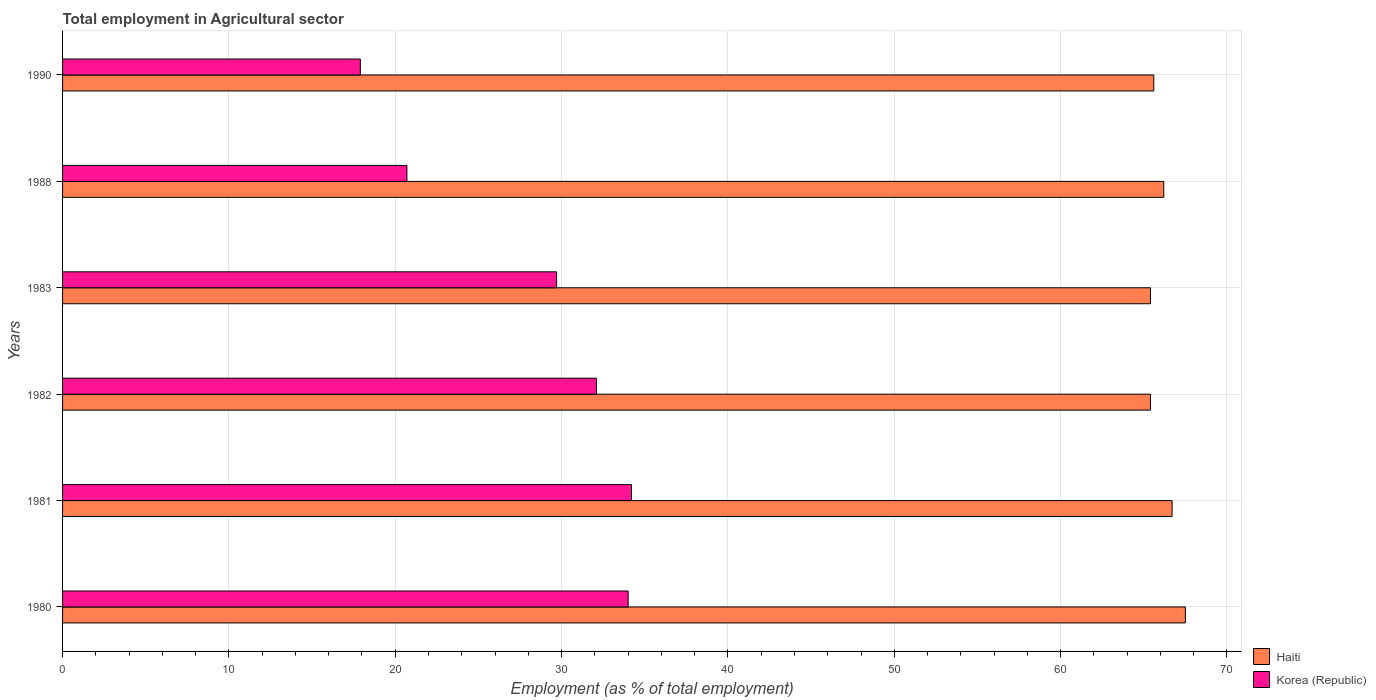Are the number of bars on each tick of the Y-axis equal?
Keep it short and to the point. Yes. How many bars are there on the 3rd tick from the bottom?
Ensure brevity in your answer.  2. What is the label of the 1st group of bars from the top?
Your answer should be very brief. 1990. What is the employment in agricultural sector in Haiti in 1980?
Your response must be concise. 67.5. Across all years, what is the maximum employment in agricultural sector in Haiti?
Give a very brief answer. 67.5. Across all years, what is the minimum employment in agricultural sector in Haiti?
Your answer should be very brief. 65.4. In which year was the employment in agricultural sector in Korea (Republic) maximum?
Ensure brevity in your answer.  1981. In which year was the employment in agricultural sector in Korea (Republic) minimum?
Keep it short and to the point. 1990. What is the total employment in agricultural sector in Korea (Republic) in the graph?
Your response must be concise. 168.6. What is the difference between the employment in agricultural sector in Haiti in 1983 and that in 1988?
Keep it short and to the point. -0.8. What is the difference between the employment in agricultural sector in Korea (Republic) in 1981 and the employment in agricultural sector in Haiti in 1980?
Your answer should be compact. -33.3. What is the average employment in agricultural sector in Korea (Republic) per year?
Offer a terse response. 28.1. In the year 1988, what is the difference between the employment in agricultural sector in Korea (Republic) and employment in agricultural sector in Haiti?
Provide a succinct answer. -45.5. In how many years, is the employment in agricultural sector in Korea (Republic) greater than 44 %?
Your answer should be compact. 0. What is the ratio of the employment in agricultural sector in Korea (Republic) in 1980 to that in 1982?
Offer a very short reply. 1.06. What is the difference between the highest and the second highest employment in agricultural sector in Korea (Republic)?
Your response must be concise. 0.2. What is the difference between the highest and the lowest employment in agricultural sector in Haiti?
Provide a short and direct response. 2.1. In how many years, is the employment in agricultural sector in Korea (Republic) greater than the average employment in agricultural sector in Korea (Republic) taken over all years?
Offer a terse response. 4. What does the 2nd bar from the top in 1990 represents?
Ensure brevity in your answer.  Haiti. Are all the bars in the graph horizontal?
Your answer should be compact. Yes. Are the values on the major ticks of X-axis written in scientific E-notation?
Your response must be concise. No. Does the graph contain grids?
Offer a very short reply. Yes. How are the legend labels stacked?
Your answer should be compact. Vertical. What is the title of the graph?
Provide a short and direct response. Total employment in Agricultural sector. What is the label or title of the X-axis?
Make the answer very short. Employment (as % of total employment). What is the label or title of the Y-axis?
Give a very brief answer. Years. What is the Employment (as % of total employment) of Haiti in 1980?
Give a very brief answer. 67.5. What is the Employment (as % of total employment) in Korea (Republic) in 1980?
Ensure brevity in your answer.  34. What is the Employment (as % of total employment) of Haiti in 1981?
Ensure brevity in your answer.  66.7. What is the Employment (as % of total employment) of Korea (Republic) in 1981?
Give a very brief answer. 34.2. What is the Employment (as % of total employment) of Haiti in 1982?
Offer a very short reply. 65.4. What is the Employment (as % of total employment) of Korea (Republic) in 1982?
Provide a short and direct response. 32.1. What is the Employment (as % of total employment) in Haiti in 1983?
Give a very brief answer. 65.4. What is the Employment (as % of total employment) of Korea (Republic) in 1983?
Provide a short and direct response. 29.7. What is the Employment (as % of total employment) of Haiti in 1988?
Offer a very short reply. 66.2. What is the Employment (as % of total employment) in Korea (Republic) in 1988?
Your response must be concise. 20.7. What is the Employment (as % of total employment) in Haiti in 1990?
Your response must be concise. 65.6. What is the Employment (as % of total employment) in Korea (Republic) in 1990?
Provide a short and direct response. 17.9. Across all years, what is the maximum Employment (as % of total employment) in Haiti?
Offer a terse response. 67.5. Across all years, what is the maximum Employment (as % of total employment) in Korea (Republic)?
Give a very brief answer. 34.2. Across all years, what is the minimum Employment (as % of total employment) in Haiti?
Offer a very short reply. 65.4. Across all years, what is the minimum Employment (as % of total employment) of Korea (Republic)?
Provide a succinct answer. 17.9. What is the total Employment (as % of total employment) in Haiti in the graph?
Give a very brief answer. 396.8. What is the total Employment (as % of total employment) in Korea (Republic) in the graph?
Give a very brief answer. 168.6. What is the difference between the Employment (as % of total employment) of Haiti in 1980 and that in 1981?
Provide a succinct answer. 0.8. What is the difference between the Employment (as % of total employment) of Korea (Republic) in 1980 and that in 1981?
Your response must be concise. -0.2. What is the difference between the Employment (as % of total employment) of Haiti in 1980 and that in 1982?
Make the answer very short. 2.1. What is the difference between the Employment (as % of total employment) in Korea (Republic) in 1980 and that in 1982?
Your answer should be compact. 1.9. What is the difference between the Employment (as % of total employment) of Haiti in 1980 and that in 1988?
Ensure brevity in your answer.  1.3. What is the difference between the Employment (as % of total employment) of Haiti in 1980 and that in 1990?
Ensure brevity in your answer.  1.9. What is the difference between the Employment (as % of total employment) of Korea (Republic) in 1980 and that in 1990?
Provide a short and direct response. 16.1. What is the difference between the Employment (as % of total employment) in Korea (Republic) in 1981 and that in 1982?
Offer a terse response. 2.1. What is the difference between the Employment (as % of total employment) of Korea (Republic) in 1981 and that in 1983?
Provide a short and direct response. 4.5. What is the difference between the Employment (as % of total employment) in Haiti in 1981 and that in 1988?
Provide a succinct answer. 0.5. What is the difference between the Employment (as % of total employment) of Korea (Republic) in 1981 and that in 1988?
Offer a very short reply. 13.5. What is the difference between the Employment (as % of total employment) of Korea (Republic) in 1981 and that in 1990?
Provide a succinct answer. 16.3. What is the difference between the Employment (as % of total employment) of Korea (Republic) in 1982 and that in 1983?
Make the answer very short. 2.4. What is the difference between the Employment (as % of total employment) in Haiti in 1982 and that in 1990?
Offer a terse response. -0.2. What is the difference between the Employment (as % of total employment) of Korea (Republic) in 1983 and that in 1988?
Keep it short and to the point. 9. What is the difference between the Employment (as % of total employment) of Haiti in 1983 and that in 1990?
Offer a very short reply. -0.2. What is the difference between the Employment (as % of total employment) of Korea (Republic) in 1988 and that in 1990?
Make the answer very short. 2.8. What is the difference between the Employment (as % of total employment) of Haiti in 1980 and the Employment (as % of total employment) of Korea (Republic) in 1981?
Give a very brief answer. 33.3. What is the difference between the Employment (as % of total employment) in Haiti in 1980 and the Employment (as % of total employment) in Korea (Republic) in 1982?
Provide a succinct answer. 35.4. What is the difference between the Employment (as % of total employment) of Haiti in 1980 and the Employment (as % of total employment) of Korea (Republic) in 1983?
Offer a terse response. 37.8. What is the difference between the Employment (as % of total employment) of Haiti in 1980 and the Employment (as % of total employment) of Korea (Republic) in 1988?
Your answer should be very brief. 46.8. What is the difference between the Employment (as % of total employment) in Haiti in 1980 and the Employment (as % of total employment) in Korea (Republic) in 1990?
Your answer should be very brief. 49.6. What is the difference between the Employment (as % of total employment) in Haiti in 1981 and the Employment (as % of total employment) in Korea (Republic) in 1982?
Make the answer very short. 34.6. What is the difference between the Employment (as % of total employment) in Haiti in 1981 and the Employment (as % of total employment) in Korea (Republic) in 1983?
Offer a very short reply. 37. What is the difference between the Employment (as % of total employment) in Haiti in 1981 and the Employment (as % of total employment) in Korea (Republic) in 1988?
Provide a short and direct response. 46. What is the difference between the Employment (as % of total employment) of Haiti in 1981 and the Employment (as % of total employment) of Korea (Republic) in 1990?
Provide a short and direct response. 48.8. What is the difference between the Employment (as % of total employment) in Haiti in 1982 and the Employment (as % of total employment) in Korea (Republic) in 1983?
Offer a very short reply. 35.7. What is the difference between the Employment (as % of total employment) of Haiti in 1982 and the Employment (as % of total employment) of Korea (Republic) in 1988?
Your response must be concise. 44.7. What is the difference between the Employment (as % of total employment) of Haiti in 1982 and the Employment (as % of total employment) of Korea (Republic) in 1990?
Offer a very short reply. 47.5. What is the difference between the Employment (as % of total employment) in Haiti in 1983 and the Employment (as % of total employment) in Korea (Republic) in 1988?
Ensure brevity in your answer.  44.7. What is the difference between the Employment (as % of total employment) of Haiti in 1983 and the Employment (as % of total employment) of Korea (Republic) in 1990?
Offer a terse response. 47.5. What is the difference between the Employment (as % of total employment) in Haiti in 1988 and the Employment (as % of total employment) in Korea (Republic) in 1990?
Make the answer very short. 48.3. What is the average Employment (as % of total employment) of Haiti per year?
Offer a very short reply. 66.13. What is the average Employment (as % of total employment) of Korea (Republic) per year?
Make the answer very short. 28.1. In the year 1980, what is the difference between the Employment (as % of total employment) in Haiti and Employment (as % of total employment) in Korea (Republic)?
Your answer should be very brief. 33.5. In the year 1981, what is the difference between the Employment (as % of total employment) of Haiti and Employment (as % of total employment) of Korea (Republic)?
Give a very brief answer. 32.5. In the year 1982, what is the difference between the Employment (as % of total employment) of Haiti and Employment (as % of total employment) of Korea (Republic)?
Keep it short and to the point. 33.3. In the year 1983, what is the difference between the Employment (as % of total employment) of Haiti and Employment (as % of total employment) of Korea (Republic)?
Keep it short and to the point. 35.7. In the year 1988, what is the difference between the Employment (as % of total employment) of Haiti and Employment (as % of total employment) of Korea (Republic)?
Offer a very short reply. 45.5. In the year 1990, what is the difference between the Employment (as % of total employment) of Haiti and Employment (as % of total employment) of Korea (Republic)?
Offer a very short reply. 47.7. What is the ratio of the Employment (as % of total employment) in Haiti in 1980 to that in 1982?
Make the answer very short. 1.03. What is the ratio of the Employment (as % of total employment) in Korea (Republic) in 1980 to that in 1982?
Offer a very short reply. 1.06. What is the ratio of the Employment (as % of total employment) in Haiti in 1980 to that in 1983?
Your answer should be very brief. 1.03. What is the ratio of the Employment (as % of total employment) in Korea (Republic) in 1980 to that in 1983?
Ensure brevity in your answer.  1.14. What is the ratio of the Employment (as % of total employment) of Haiti in 1980 to that in 1988?
Your answer should be compact. 1.02. What is the ratio of the Employment (as % of total employment) in Korea (Republic) in 1980 to that in 1988?
Your answer should be very brief. 1.64. What is the ratio of the Employment (as % of total employment) in Korea (Republic) in 1980 to that in 1990?
Offer a very short reply. 1.9. What is the ratio of the Employment (as % of total employment) in Haiti in 1981 to that in 1982?
Offer a terse response. 1.02. What is the ratio of the Employment (as % of total employment) in Korea (Republic) in 1981 to that in 1982?
Give a very brief answer. 1.07. What is the ratio of the Employment (as % of total employment) in Haiti in 1981 to that in 1983?
Provide a short and direct response. 1.02. What is the ratio of the Employment (as % of total employment) of Korea (Republic) in 1981 to that in 1983?
Offer a very short reply. 1.15. What is the ratio of the Employment (as % of total employment) of Haiti in 1981 to that in 1988?
Your answer should be compact. 1.01. What is the ratio of the Employment (as % of total employment) in Korea (Republic) in 1981 to that in 1988?
Offer a terse response. 1.65. What is the ratio of the Employment (as % of total employment) of Haiti in 1981 to that in 1990?
Keep it short and to the point. 1.02. What is the ratio of the Employment (as % of total employment) in Korea (Republic) in 1981 to that in 1990?
Offer a terse response. 1.91. What is the ratio of the Employment (as % of total employment) of Haiti in 1982 to that in 1983?
Your answer should be compact. 1. What is the ratio of the Employment (as % of total employment) in Korea (Republic) in 1982 to that in 1983?
Provide a short and direct response. 1.08. What is the ratio of the Employment (as % of total employment) in Haiti in 1982 to that in 1988?
Keep it short and to the point. 0.99. What is the ratio of the Employment (as % of total employment) of Korea (Republic) in 1982 to that in 1988?
Your answer should be very brief. 1.55. What is the ratio of the Employment (as % of total employment) in Haiti in 1982 to that in 1990?
Offer a very short reply. 1. What is the ratio of the Employment (as % of total employment) in Korea (Republic) in 1982 to that in 1990?
Provide a short and direct response. 1.79. What is the ratio of the Employment (as % of total employment) of Haiti in 1983 to that in 1988?
Provide a succinct answer. 0.99. What is the ratio of the Employment (as % of total employment) in Korea (Republic) in 1983 to that in 1988?
Ensure brevity in your answer.  1.43. What is the ratio of the Employment (as % of total employment) of Korea (Republic) in 1983 to that in 1990?
Provide a succinct answer. 1.66. What is the ratio of the Employment (as % of total employment) of Haiti in 1988 to that in 1990?
Your response must be concise. 1.01. What is the ratio of the Employment (as % of total employment) in Korea (Republic) in 1988 to that in 1990?
Your answer should be very brief. 1.16. What is the difference between the highest and the second highest Employment (as % of total employment) in Haiti?
Your answer should be compact. 0.8. What is the difference between the highest and the lowest Employment (as % of total employment) in Haiti?
Keep it short and to the point. 2.1. 